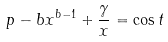Convert formula to latex. <formula><loc_0><loc_0><loc_500><loc_500>p - b x ^ { b - 1 } + \frac { \gamma } { x } = \cos t</formula> 